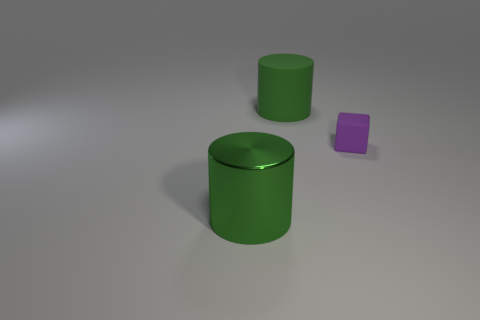Add 1 small purple spheres. How many objects exist? 4 Subtract all cylinders. How many objects are left? 1 Add 1 large brown shiny cubes. How many large brown shiny cubes exist? 1 Subtract 0 gray cylinders. How many objects are left? 3 Subtract all large red cubes. Subtract all rubber objects. How many objects are left? 1 Add 1 blocks. How many blocks are left? 2 